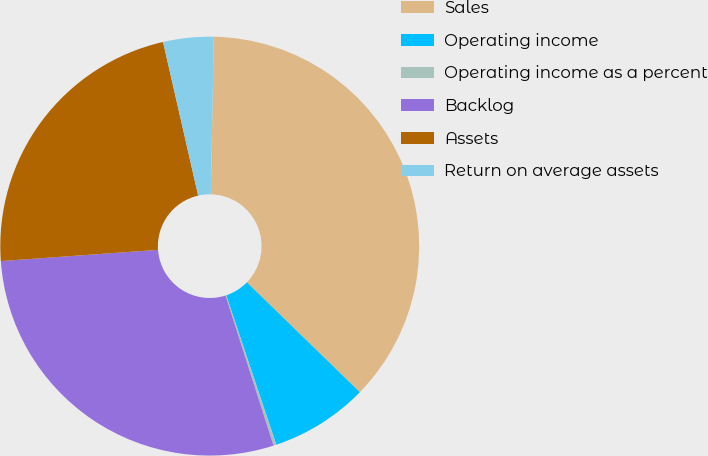Convert chart. <chart><loc_0><loc_0><loc_500><loc_500><pie_chart><fcel>Sales<fcel>Operating income<fcel>Operating income as a percent<fcel>Backlog<fcel>Assets<fcel>Return on average assets<nl><fcel>36.97%<fcel>7.57%<fcel>0.22%<fcel>28.79%<fcel>22.56%<fcel>3.89%<nl></chart> 